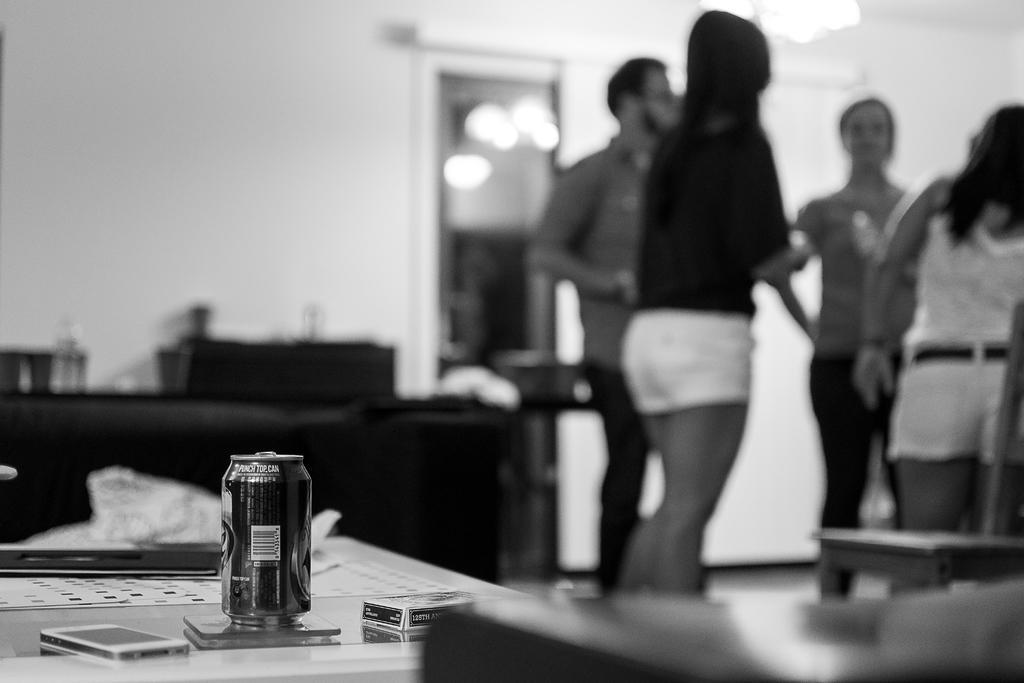Could you give a brief overview of what you see in this image? This is a blurred picture of four people standing to the left side and a table on which there is a tin, phone and some things placed on it. 